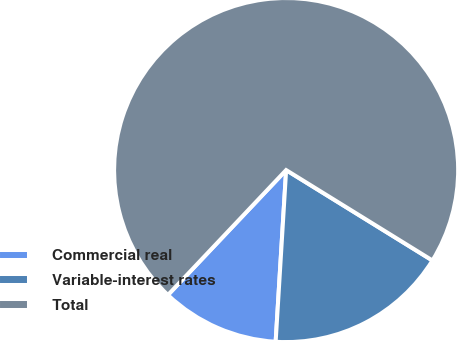Convert chart to OTSL. <chart><loc_0><loc_0><loc_500><loc_500><pie_chart><fcel>Commercial real<fcel>Variable-interest rates<fcel>Total<nl><fcel>11.09%<fcel>17.16%<fcel>71.75%<nl></chart> 